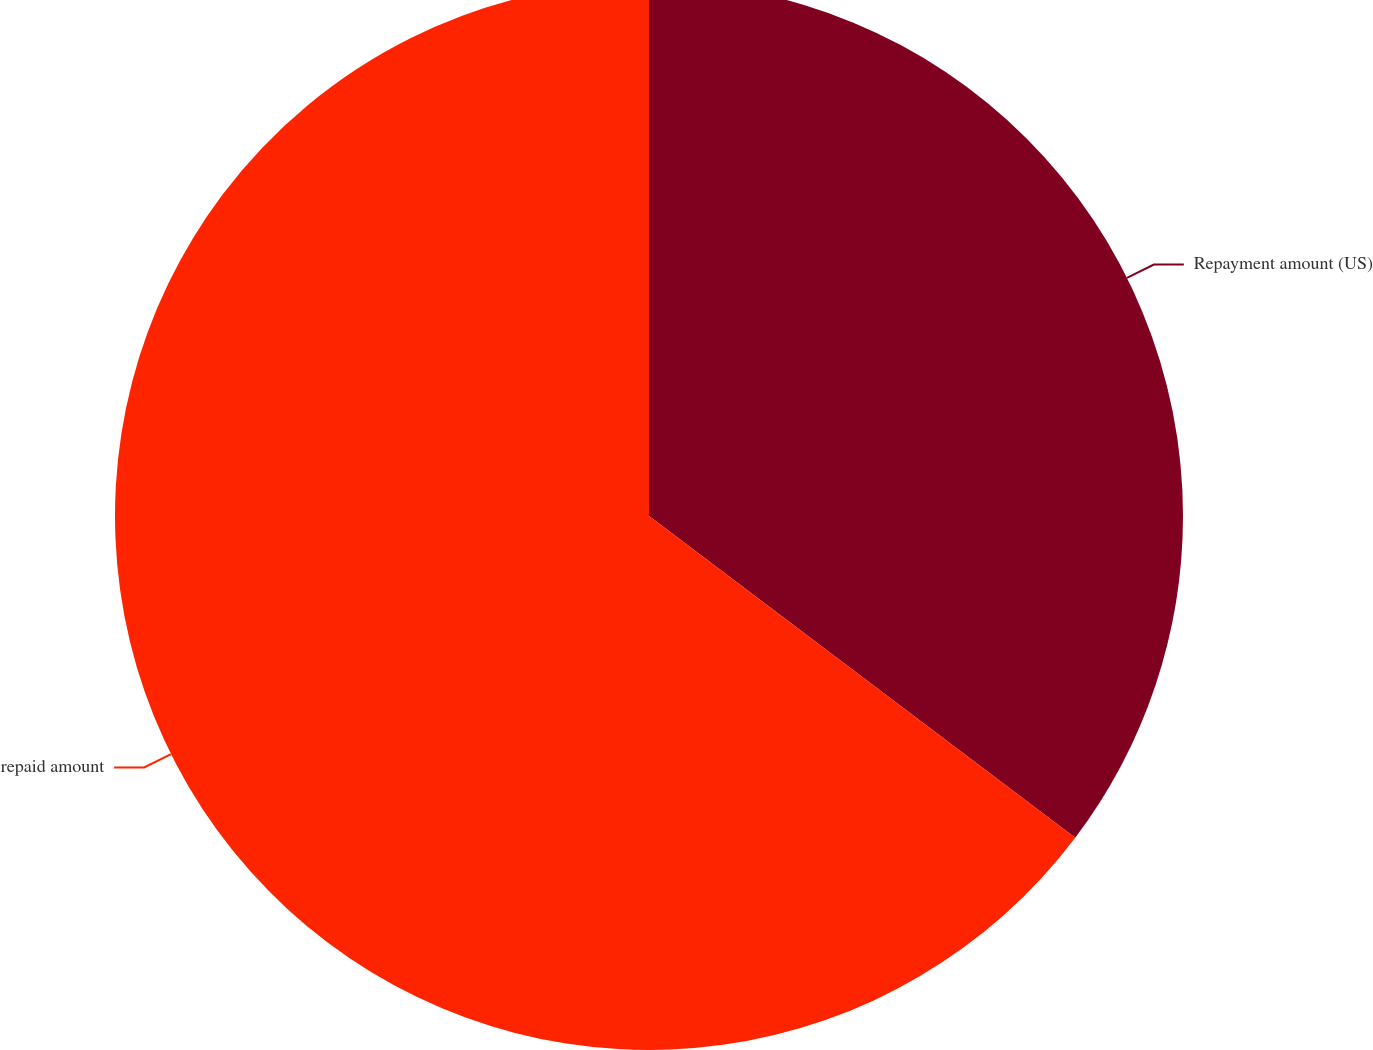Convert chart. <chart><loc_0><loc_0><loc_500><loc_500><pie_chart><fcel>Repayment amount (US)<fcel>repaid amount<nl><fcel>35.29%<fcel>64.71%<nl></chart> 